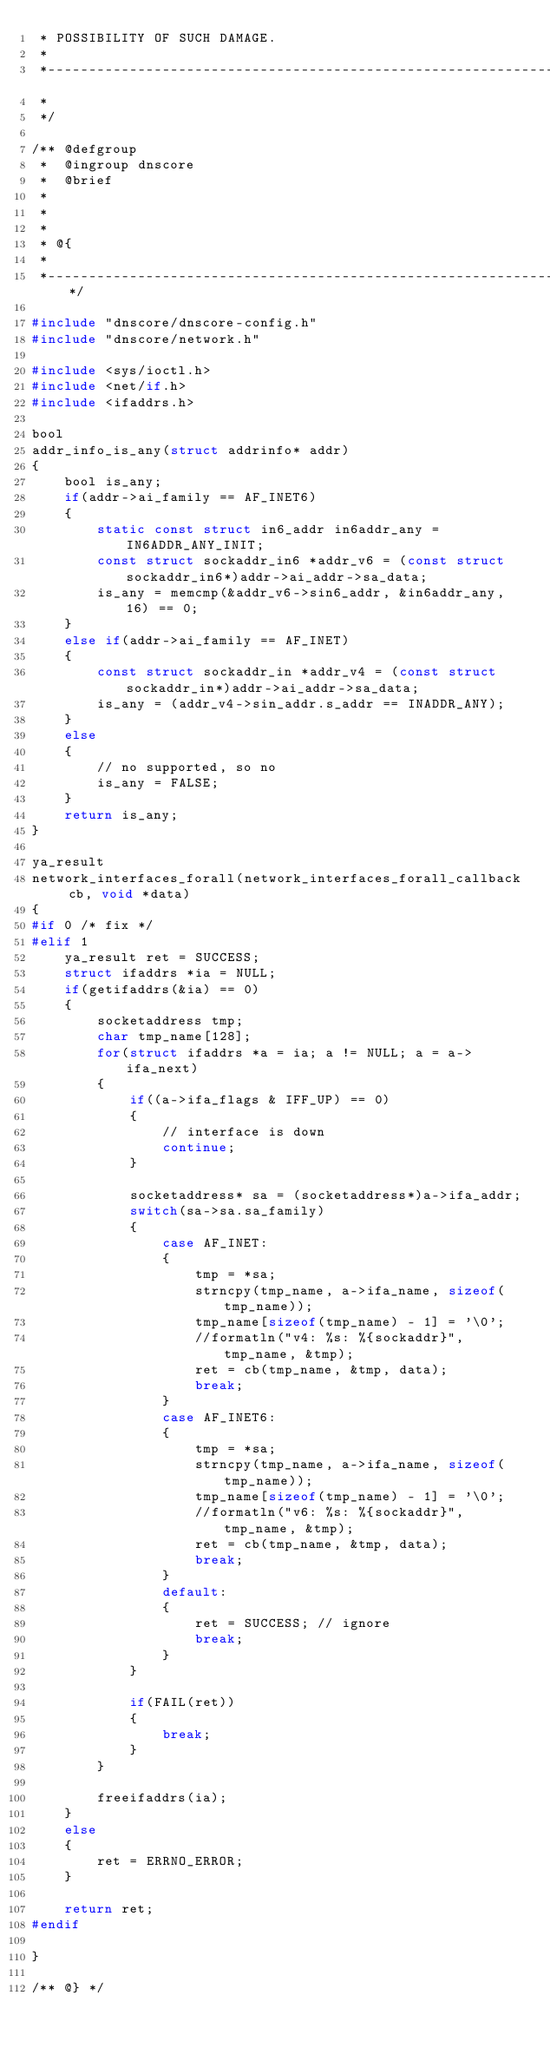Convert code to text. <code><loc_0><loc_0><loc_500><loc_500><_C_> * POSSIBILITY OF SUCH DAMAGE.
 *
 *------------------------------------------------------------------------------
 *
 */

/** @defgroup
 *  @ingroup dnscore
 *  @brief
 *
 *
 *
 * @{
 *
 *----------------------------------------------------------------------------*/

#include "dnscore/dnscore-config.h"
#include "dnscore/network.h"

#include <sys/ioctl.h>
#include <net/if.h>
#include <ifaddrs.h>

bool
addr_info_is_any(struct addrinfo* addr)
{
    bool is_any;
    if(addr->ai_family == AF_INET6)
    {
        static const struct in6_addr in6addr_any = IN6ADDR_ANY_INIT;
        const struct sockaddr_in6 *addr_v6 = (const struct sockaddr_in6*)addr->ai_addr->sa_data;
        is_any = memcmp(&addr_v6->sin6_addr, &in6addr_any, 16) == 0;
    }
    else if(addr->ai_family == AF_INET)
    {
        const struct sockaddr_in *addr_v4 = (const struct sockaddr_in*)addr->ai_addr->sa_data;
        is_any = (addr_v4->sin_addr.s_addr == INADDR_ANY);
    }
    else
    {
        // no supported, so no
        is_any = FALSE;
    }
    return is_any;
}

ya_result
network_interfaces_forall(network_interfaces_forall_callback cb, void *data)
{
#if 0 /* fix */
#elif 1
    ya_result ret = SUCCESS;
    struct ifaddrs *ia = NULL;
    if(getifaddrs(&ia) == 0)
    {
        socketaddress tmp;
        char tmp_name[128];
        for(struct ifaddrs *a = ia; a != NULL; a = a->ifa_next)
        {
            if((a->ifa_flags & IFF_UP) == 0)
            {
                // interface is down
                continue;
            }

            socketaddress* sa = (socketaddress*)a->ifa_addr;
            switch(sa->sa.sa_family)
            {
                case AF_INET:
                {
                    tmp = *sa;
                    strncpy(tmp_name, a->ifa_name, sizeof(tmp_name));
                    tmp_name[sizeof(tmp_name) - 1] = '\0';
                    //formatln("v4: %s: %{sockaddr}", tmp_name, &tmp);
                    ret = cb(tmp_name, &tmp, data);
                    break;
                }
                case AF_INET6:
                {
                    tmp = *sa;
                    strncpy(tmp_name, a->ifa_name, sizeof(tmp_name));
                    tmp_name[sizeof(tmp_name) - 1] = '\0';
                    //formatln("v6: %s: %{sockaddr}", tmp_name, &tmp);
                    ret = cb(tmp_name, &tmp, data);
                    break;
                }
                default:
                {
                    ret = SUCCESS; // ignore
                    break;
                }
            }

            if(FAIL(ret))
            {
                break;
            }
        }

        freeifaddrs(ia);
    }
    else
    {
        ret = ERRNO_ERROR;
    }

    return ret;
#endif

}

/** @} */
</code> 